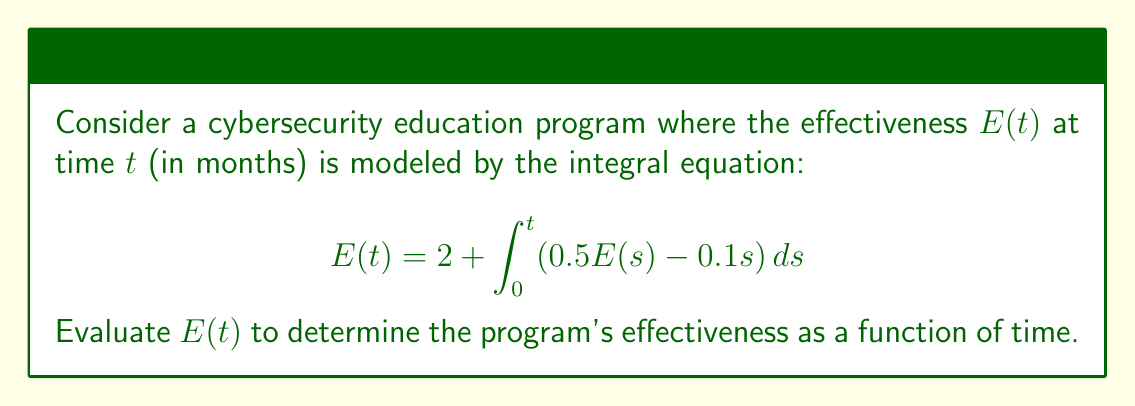Can you solve this math problem? To solve this integral equation, we'll use the following steps:

1) First, we differentiate both sides of the equation with respect to $t$:

   $$\frac{d}{dt}E(t) = \frac{d}{dt}\left(2 + \int_0^t (0.5E(s) - 0.1s) ds\right)$$

2) Using the Fundamental Theorem of Calculus:

   $$E'(t) = 0.5E(t) - 0.1t$$

3) Rearrange the equation:

   $$E'(t) - 0.5E(t) = -0.1t$$

4) This is a first-order linear differential equation. The general solution is of the form:

   $$E(t) = e^{0.5t}(C + \int -0.1t e^{-0.5t} dt)$$

5) Evaluate the integral:

   $$\int -0.1t e^{-0.5t} dt = 0.2te^{-0.5t} - 0.4e^{-0.5t} + K$$

6) Substituting back:

   $$E(t) = e^{0.5t}(C + 0.2te^{-0.5t} - 0.4e^{-0.5t} + K)$$
   $$E(t) = 0.2t + Ce^{0.5t} - 0.4$$

7) Use the initial condition $E(0) = 2$ to find $C$:

   $$2 = 0 + Ce^0 - 0.4$$
   $$C = 2.4$$

8) Therefore, the final solution is:

   $$E(t) = 0.2t + 2.4e^{0.5t} - 0.4$$

This function models the effectiveness of the cybersecurity education program over time.
Answer: $E(t) = 0.2t + 2.4e^{0.5t} - 0.4$ 